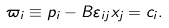<formula> <loc_0><loc_0><loc_500><loc_500>\varpi _ { i } \equiv p _ { i } - B \varepsilon _ { i j } x _ { j } = c _ { i } .</formula> 